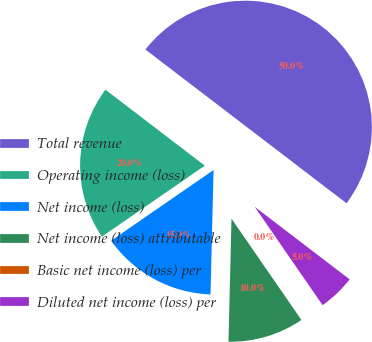Convert chart. <chart><loc_0><loc_0><loc_500><loc_500><pie_chart><fcel>Total revenue<fcel>Operating income (loss)<fcel>Net income (loss)<fcel>Net income (loss) attributable<fcel>Basic net income (loss) per<fcel>Diluted net income (loss) per<nl><fcel>50.0%<fcel>20.0%<fcel>15.0%<fcel>10.0%<fcel>0.0%<fcel>5.0%<nl></chart> 